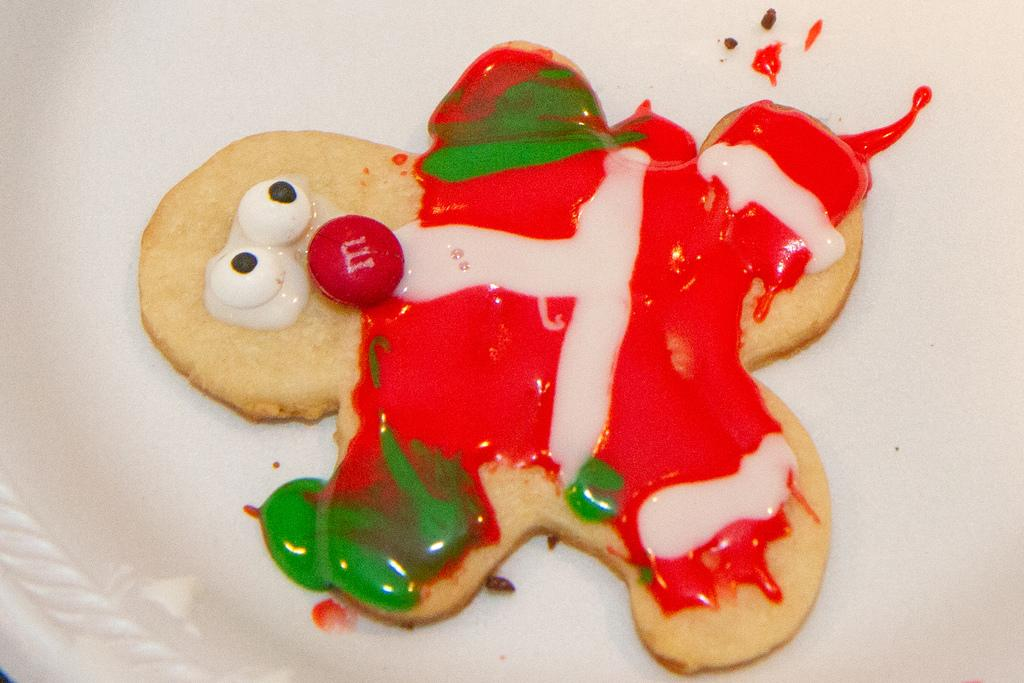What is the main subject of the image? There is a food item in the image. What is the food item placed on? The food item is on a white object. How many horses can be seen in the image? There are no horses present in the image. Is there a cobweb visible on the food item in the image? There is no mention of a cobweb in the provided facts, so we cannot determine if one is present. 